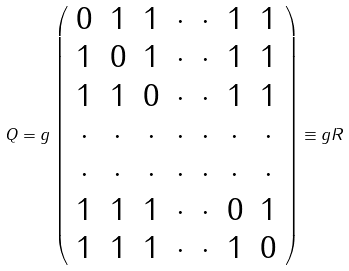Convert formula to latex. <formula><loc_0><loc_0><loc_500><loc_500>Q = g \left ( \begin{array} { c c c c c c c } 0 & 1 & 1 & \cdot & \cdot & 1 & 1 \\ 1 & 0 & 1 & \cdot & \cdot & 1 & 1 \\ 1 & 1 & 0 & \cdot & \cdot & 1 & 1 \\ \cdot & \cdot & \cdot & \cdot & \cdot & \cdot & \cdot \\ \cdot & \cdot & \cdot & \cdot & \cdot & \cdot & \cdot \\ 1 & 1 & 1 & \cdot & \cdot & 0 & 1 \\ 1 & 1 & 1 & \cdot & \cdot & 1 & 0 \end{array} \right ) \equiv g R</formula> 